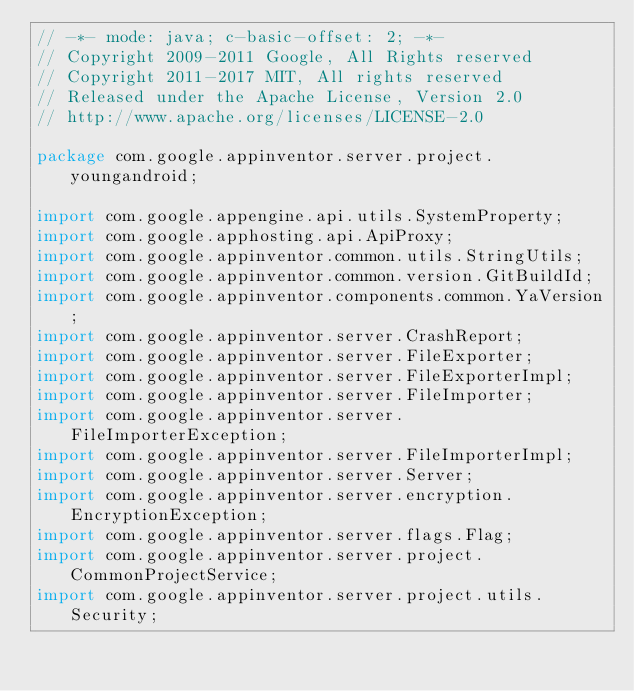<code> <loc_0><loc_0><loc_500><loc_500><_Java_>// -*- mode: java; c-basic-offset: 2; -*-
// Copyright 2009-2011 Google, All Rights reserved
// Copyright 2011-2017 MIT, All rights reserved
// Released under the Apache License, Version 2.0
// http://www.apache.org/licenses/LICENSE-2.0

package com.google.appinventor.server.project.youngandroid;

import com.google.appengine.api.utils.SystemProperty;
import com.google.apphosting.api.ApiProxy;
import com.google.appinventor.common.utils.StringUtils;
import com.google.appinventor.common.version.GitBuildId;
import com.google.appinventor.components.common.YaVersion;
import com.google.appinventor.server.CrashReport;
import com.google.appinventor.server.FileExporter;
import com.google.appinventor.server.FileExporterImpl;
import com.google.appinventor.server.FileImporter;
import com.google.appinventor.server.FileImporterException;
import com.google.appinventor.server.FileImporterImpl;
import com.google.appinventor.server.Server;
import com.google.appinventor.server.encryption.EncryptionException;
import com.google.appinventor.server.flags.Flag;
import com.google.appinventor.server.project.CommonProjectService;
import com.google.appinventor.server.project.utils.Security;</code> 